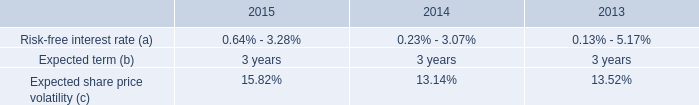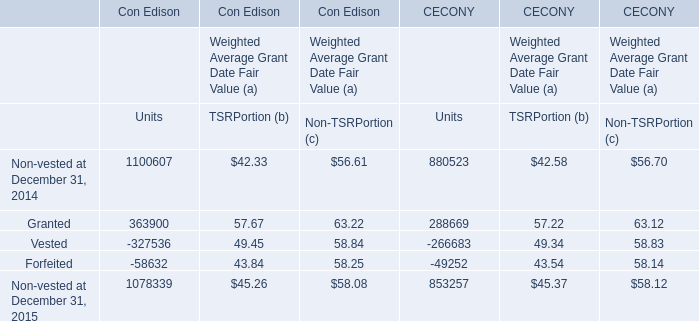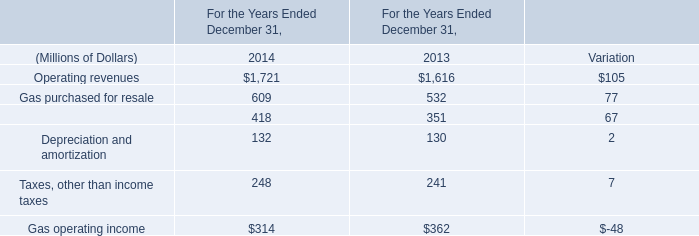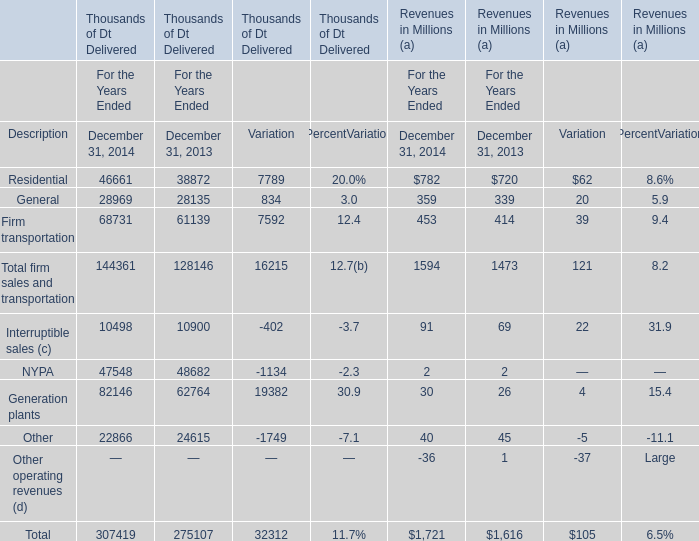What's the sum of Residential of Thousands of Dt Delivered Variation, and Forfeited of Con Edison Units ? 
Computations: (7789.0 + 58632.0)
Answer: 66421.0. 